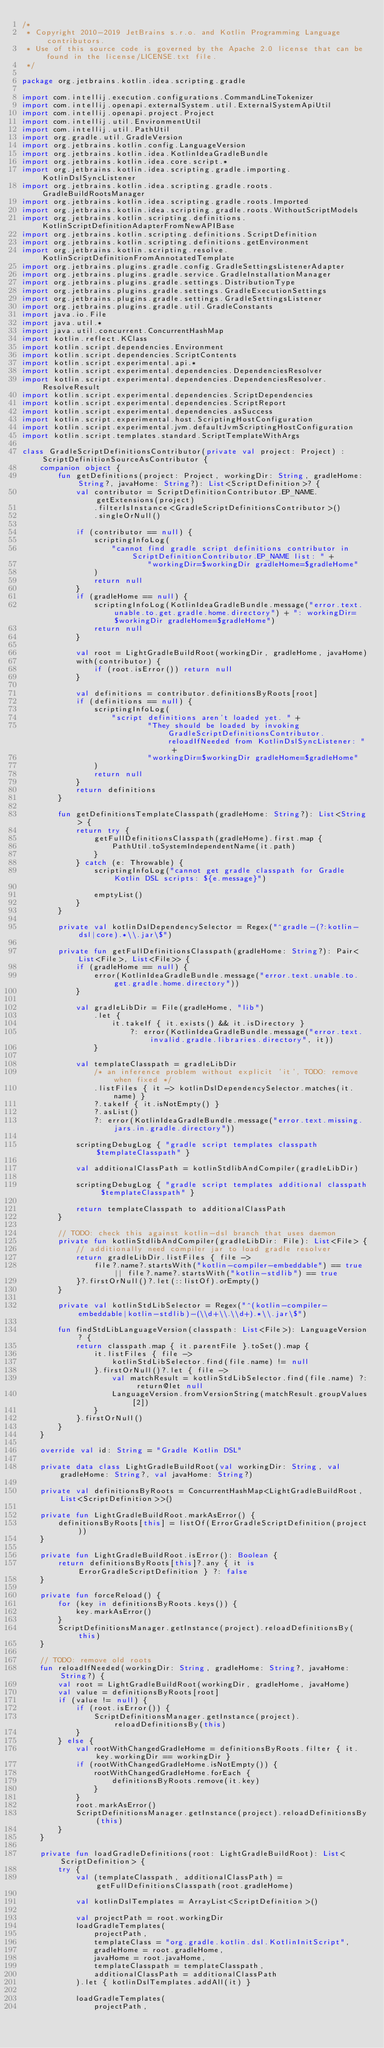<code> <loc_0><loc_0><loc_500><loc_500><_Kotlin_>/*
 * Copyright 2010-2019 JetBrains s.r.o. and Kotlin Programming Language contributors.
 * Use of this source code is governed by the Apache 2.0 license that can be found in the license/LICENSE.txt file.
 */

package org.jetbrains.kotlin.idea.scripting.gradle

import com.intellij.execution.configurations.CommandLineTokenizer
import com.intellij.openapi.externalSystem.util.ExternalSystemApiUtil
import com.intellij.openapi.project.Project
import com.intellij.util.EnvironmentUtil
import com.intellij.util.PathUtil
import org.gradle.util.GradleVersion
import org.jetbrains.kotlin.config.LanguageVersion
import org.jetbrains.kotlin.idea.KotlinIdeaGradleBundle
import org.jetbrains.kotlin.idea.core.script.*
import org.jetbrains.kotlin.idea.scripting.gradle.importing.KotlinDslSyncListener
import org.jetbrains.kotlin.idea.scripting.gradle.roots.GradleBuildRootsManager
import org.jetbrains.kotlin.idea.scripting.gradle.roots.Imported
import org.jetbrains.kotlin.idea.scripting.gradle.roots.WithoutScriptModels
import org.jetbrains.kotlin.scripting.definitions.KotlinScriptDefinitionAdapterFromNewAPIBase
import org.jetbrains.kotlin.scripting.definitions.ScriptDefinition
import org.jetbrains.kotlin.scripting.definitions.getEnvironment
import org.jetbrains.kotlin.scripting.resolve.KotlinScriptDefinitionFromAnnotatedTemplate
import org.jetbrains.plugins.gradle.config.GradleSettingsListenerAdapter
import org.jetbrains.plugins.gradle.service.GradleInstallationManager
import org.jetbrains.plugins.gradle.settings.DistributionType
import org.jetbrains.plugins.gradle.settings.GradleExecutionSettings
import org.jetbrains.plugins.gradle.settings.GradleSettingsListener
import org.jetbrains.plugins.gradle.util.GradleConstants
import java.io.File
import java.util.*
import java.util.concurrent.ConcurrentHashMap
import kotlin.reflect.KClass
import kotlin.script.dependencies.Environment
import kotlin.script.dependencies.ScriptContents
import kotlin.script.experimental.api.*
import kotlin.script.experimental.dependencies.DependenciesResolver
import kotlin.script.experimental.dependencies.DependenciesResolver.ResolveResult
import kotlin.script.experimental.dependencies.ScriptDependencies
import kotlin.script.experimental.dependencies.ScriptReport
import kotlin.script.experimental.dependencies.asSuccess
import kotlin.script.experimental.host.ScriptingHostConfiguration
import kotlin.script.experimental.jvm.defaultJvmScriptingHostConfiguration
import kotlin.script.templates.standard.ScriptTemplateWithArgs

class GradleScriptDefinitionsContributor(private val project: Project) : ScriptDefinitionSourceAsContributor {
    companion object {
        fun getDefinitions(project: Project, workingDir: String, gradleHome: String?, javaHome: String?): List<ScriptDefinition>? {
            val contributor = ScriptDefinitionContributor.EP_NAME.getExtensions(project)
                .filterIsInstance<GradleScriptDefinitionsContributor>()
                .singleOrNull()

            if (contributor == null) {
                scriptingInfoLog(
                    "cannot find gradle script definitions contributor in ScriptDefinitionContributor.EP_NAME list: " +
                            "workingDir=$workingDir gradleHome=$gradleHome"
                )
                return null
            }
            if (gradleHome == null) {
                scriptingInfoLog(KotlinIdeaGradleBundle.message("error.text.unable.to.get.gradle.home.directory") + ": workingDir=$workingDir gradleHome=$gradleHome")
                return null
            }

            val root = LightGradleBuildRoot(workingDir, gradleHome, javaHome)
            with(contributor) {
                if (root.isError()) return null
            }

            val definitions = contributor.definitionsByRoots[root]
            if (definitions == null) {
                scriptingInfoLog(
                    "script definitions aren't loaded yet. " +
                            "They should be loaded by invoking GradleScriptDefinitionsContributor.reloadIfNeeded from KotlinDslSyncListener: " +
                            "workingDir=$workingDir gradleHome=$gradleHome"
                )
                return null
            }
            return definitions
        }

        fun getDefinitionsTemplateClasspath(gradleHome: String?): List<String> {
            return try {
                getFullDefinitionsClasspath(gradleHome).first.map {
                    PathUtil.toSystemIndependentName(it.path)
                }
            } catch (e: Throwable) {
                scriptingInfoLog("cannot get gradle classpath for Gradle Kotlin DSL scripts: ${e.message}")

                emptyList()
            }
        }

        private val kotlinDslDependencySelector = Regex("^gradle-(?:kotlin-dsl|core).*\\.jar\$")

        private fun getFullDefinitionsClasspath(gradleHome: String?): Pair<List<File>, List<File>> {
            if (gradleHome == null) {
                error(KotlinIdeaGradleBundle.message("error.text.unable.to.get.gradle.home.directory"))
            }

            val gradleLibDir = File(gradleHome, "lib")
                .let {
                    it.takeIf { it.exists() && it.isDirectory }
                        ?: error(KotlinIdeaGradleBundle.message("error.text.invalid.gradle.libraries.directory", it))
                }

            val templateClasspath = gradleLibDir
                /* an inference problem without explicit 'it', TODO: remove when fixed */
                .listFiles { it -> kotlinDslDependencySelector.matches(it.name) }
                ?.takeIf { it.isNotEmpty() }
                ?.asList()
                ?: error(KotlinIdeaGradleBundle.message("error.text.missing.jars.in.gradle.directory"))

            scriptingDebugLog { "gradle script templates classpath $templateClasspath" }

            val additionalClassPath = kotlinStdlibAndCompiler(gradleLibDir)

            scriptingDebugLog { "gradle script templates additional classpath $templateClasspath" }

            return templateClasspath to additionalClassPath
        }

        // TODO: check this against kotlin-dsl branch that uses daemon
        private fun kotlinStdlibAndCompiler(gradleLibDir: File): List<File> {
            // additionally need compiler jar to load gradle resolver
            return gradleLibDir.listFiles { file ->
                file?.name?.startsWith("kotlin-compiler-embeddable") == true || file?.name?.startsWith("kotlin-stdlib") == true
            }?.firstOrNull()?.let(::listOf).orEmpty()
        }

        private val kotlinStdLibSelector = Regex("^(kotlin-compiler-embeddable|kotlin-stdlib)-(\\d+\\.\\d+).*\\.jar\$")

        fun findStdLibLanguageVersion(classpath: List<File>): LanguageVersion? {
            return classpath.map { it.parentFile }.toSet().map {
                it.listFiles { file ->
                    kotlinStdLibSelector.find(file.name) != null
                }.firstOrNull()?.let { file ->
                    val matchResult = kotlinStdLibSelector.find(file.name) ?: return@let null
                    LanguageVersion.fromVersionString(matchResult.groupValues[2])
                }
            }.firstOrNull()
        }
    }

    override val id: String = "Gradle Kotlin DSL"

    private data class LightGradleBuildRoot(val workingDir: String, val gradleHome: String?, val javaHome: String?)

    private val definitionsByRoots = ConcurrentHashMap<LightGradleBuildRoot, List<ScriptDefinition>>()

    private fun LightGradleBuildRoot.markAsError() {
        definitionsByRoots[this] = listOf(ErrorGradleScriptDefinition(project))
    }

    private fun LightGradleBuildRoot.isError(): Boolean {
        return definitionsByRoots[this]?.any { it is ErrorGradleScriptDefinition } ?: false
    }

    private fun forceReload() {
        for (key in definitionsByRoots.keys()) {
            key.markAsError()
        }
        ScriptDefinitionsManager.getInstance(project).reloadDefinitionsBy(this)
    }

    // TODO: remove old roots
    fun reloadIfNeeded(workingDir: String, gradleHome: String?, javaHome: String?) {
        val root = LightGradleBuildRoot(workingDir, gradleHome, javaHome)
        val value = definitionsByRoots[root]
        if (value != null) {
            if (root.isError()) {
                ScriptDefinitionsManager.getInstance(project).reloadDefinitionsBy(this)
            }
        } else {
            val rootWithChangedGradleHome = definitionsByRoots.filter { it.key.workingDir == workingDir }
            if (rootWithChangedGradleHome.isNotEmpty()) {
                rootWithChangedGradleHome.forEach {
                    definitionsByRoots.remove(it.key)
                }
            }
            root.markAsError()
            ScriptDefinitionsManager.getInstance(project).reloadDefinitionsBy(this)
        }
    }

    private fun loadGradleDefinitions(root: LightGradleBuildRoot): List<ScriptDefinition> {
        try {
            val (templateClasspath, additionalClassPath) = getFullDefinitionsClasspath(root.gradleHome)

            val kotlinDslTemplates = ArrayList<ScriptDefinition>()

            val projectPath = root.workingDir
            loadGradleTemplates(
                projectPath,
                templateClass = "org.gradle.kotlin.dsl.KotlinInitScript",
                gradleHome = root.gradleHome,
                javaHome = root.javaHome,
                templateClasspath = templateClasspath,
                additionalClassPath = additionalClassPath
            ).let { kotlinDslTemplates.addAll(it) }

            loadGradleTemplates(
                projectPath,</code> 